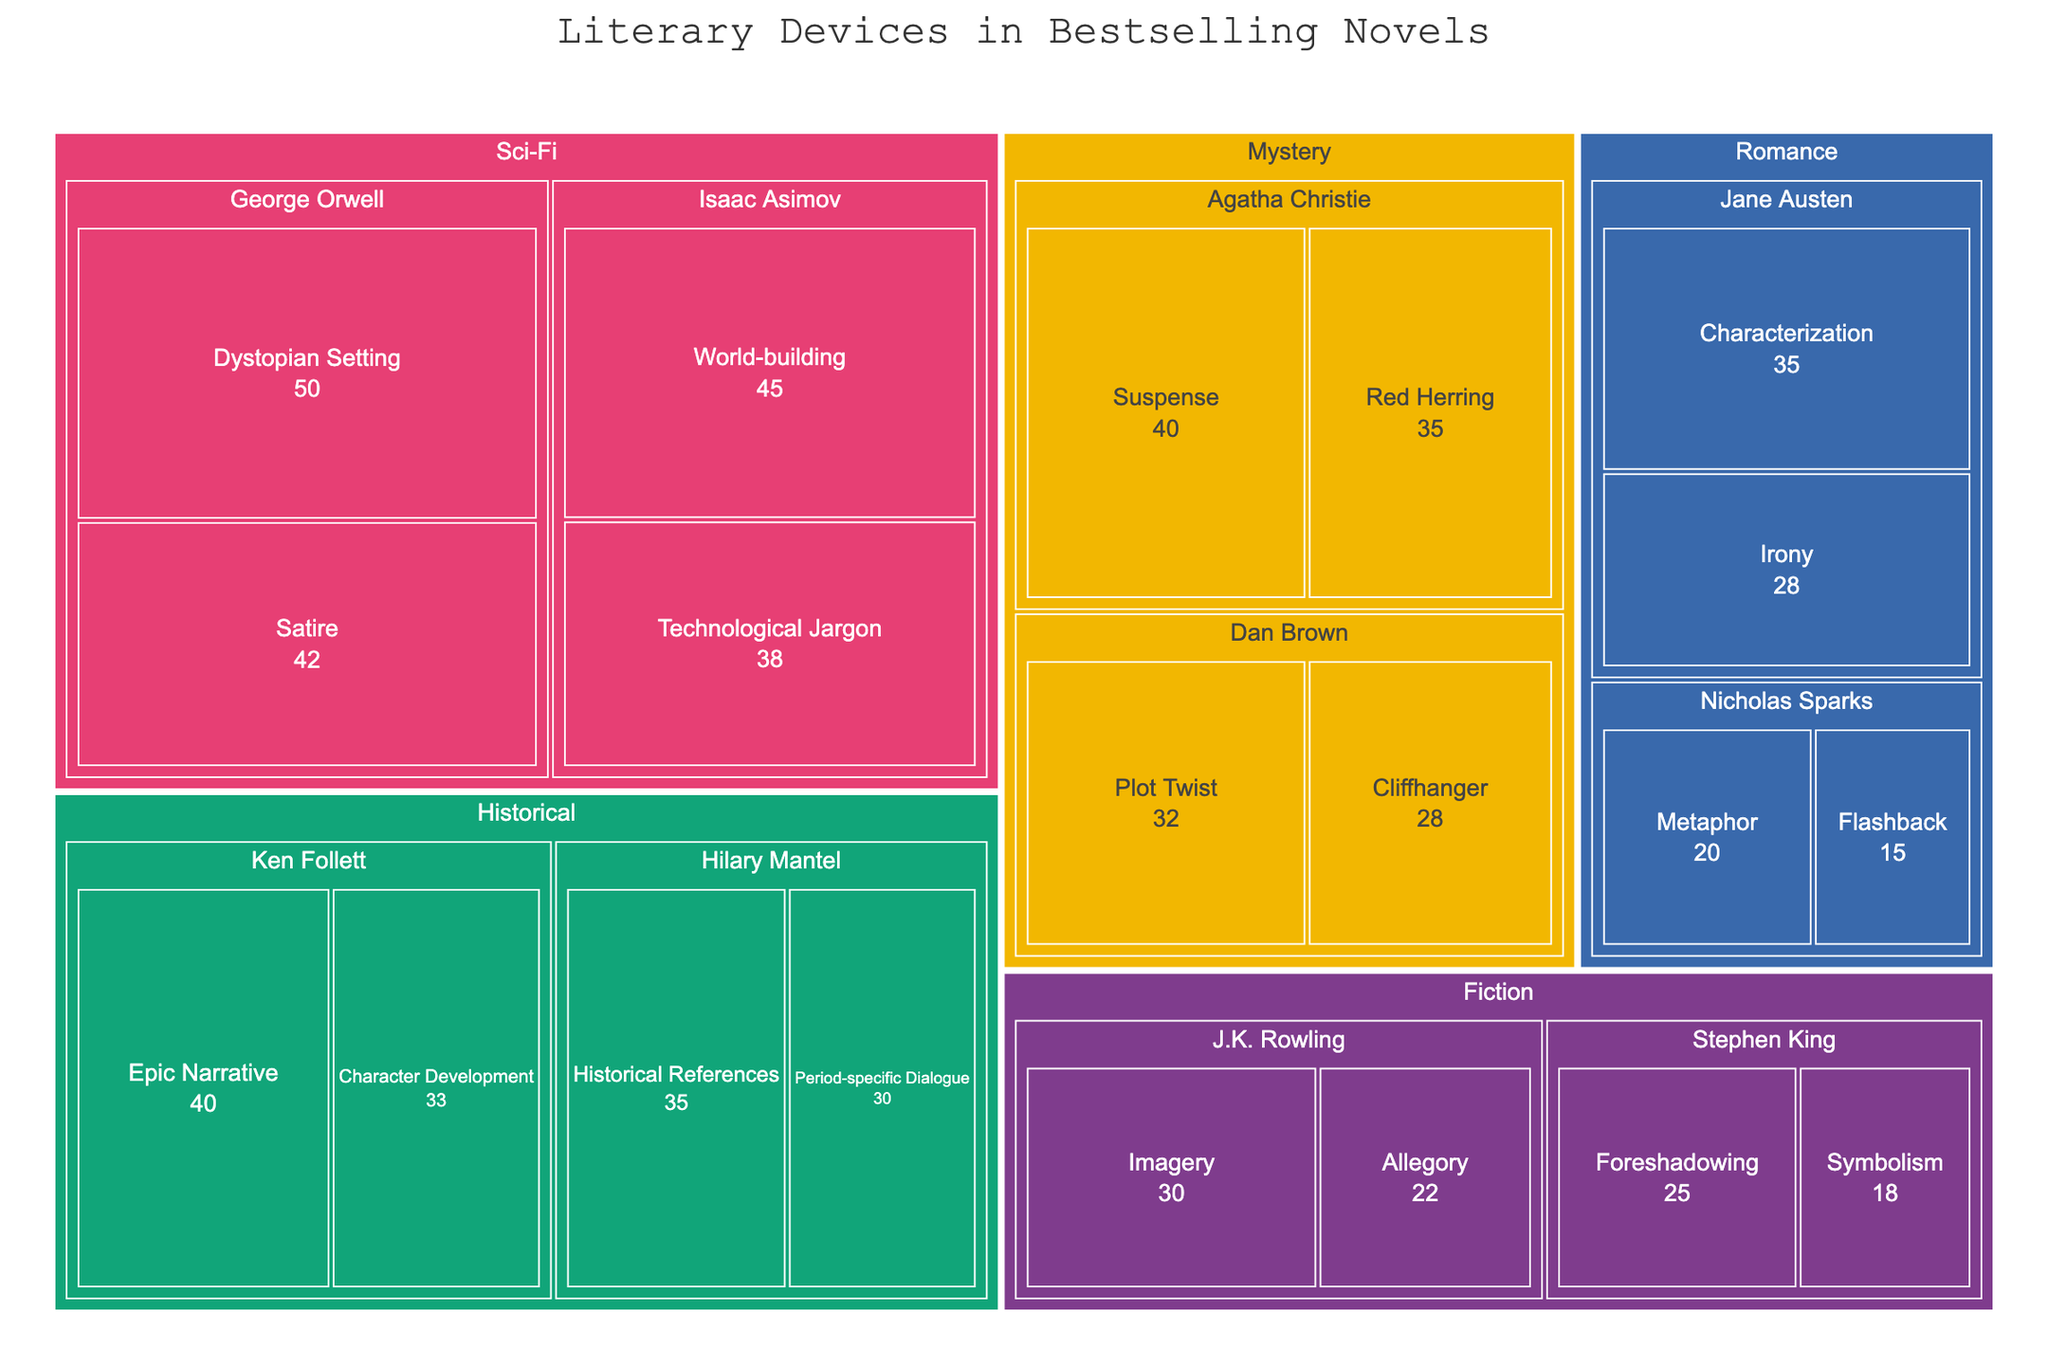What literary device is most frequently used by Agatha Christie? To find the most frequently used literary device by Agatha Christie, look for her name under the Mystery genre and compare the frequencies of the associated literary devices. Red Herring has a frequency of 35 and Suspense has a frequency of 40. Therefore, Suspense is the most frequently used device by Agatha Christie.
Answer: Suspense What is the title of the treemap figure? The title of the figure is typically displayed prominently at the top of the treemap. It reads, "Literary Devices in Bestselling Novels."
Answer: Literary Devices in Bestselling Novels How many authors are there in the Sci-Fi genre and who are they? Locate the "Sci-Fi" category in the treemap and count the number of author names listed under it. The authors listed are Isaac Asimov and George Orwell.
Answer: 2, Isaac Asimov and George Orwell Which genre has the highest frequency for any literary device, and what is that device? Scan through the genres and identify the literary device with the highest frequency. George Orwell's "Dystopian Setting" under Sci-Fi has a frequency of 50, which is the highest among all devices across all genres.
Answer: Sci-Fi, Dystopian Setting Compare the use of "Symbolism" by Stephen King to "Red Herring" by Agatha Christie. Locate Symbolism under Stephen King's name in the Fiction genre and Red Herring under Agatha Christie's name in the Mystery genre. Symbolism has a frequency of 18, whereas Red Herring has a frequency of 35. Comparing these, Symbolism is used less frequently than Red Herring.
Answer: Red Herring is more frequent How many literary devices used by Dan Brown have a frequency greater than 30? Find Dan Brown under the Mystery genre and check the frequencies of his literary devices. Cliffhanger has a frequency of 28 and Plot Twist has a frequency of 32. Only Plot Twist has a frequency greater than 30.
Answer: 1 What is the average frequency of the literary devices used by J.K. Rowling? J.K. Rowling has two literary devices: Allegory with a frequency of 22 and Imagery with a frequency of 30. Calculate the average by adding these and dividing by 2: (22 + 30) / 2 = 52 / 2.
Answer: 26 Which genre has the most diverse usage of literary devices in terms of the number of different devices? Compare the number of literary devices listed under each genre. Sci-Fi has four different devices used (World-building, Technological Jargon, Dystopian Setting, Satire), which is the highest among all genres.
Answer: Sci-Fi If you combine the frequencies of "Metaphor" and "Flashback" in the Romance genre, what is the total? Locate Metaphor and Flashback under Nicholas Sparks in the Romance genre. Metaphor has a frequency of 20 and Flashback has a frequency of 15. Adding these gives 20 + 15.
Answer: 35 